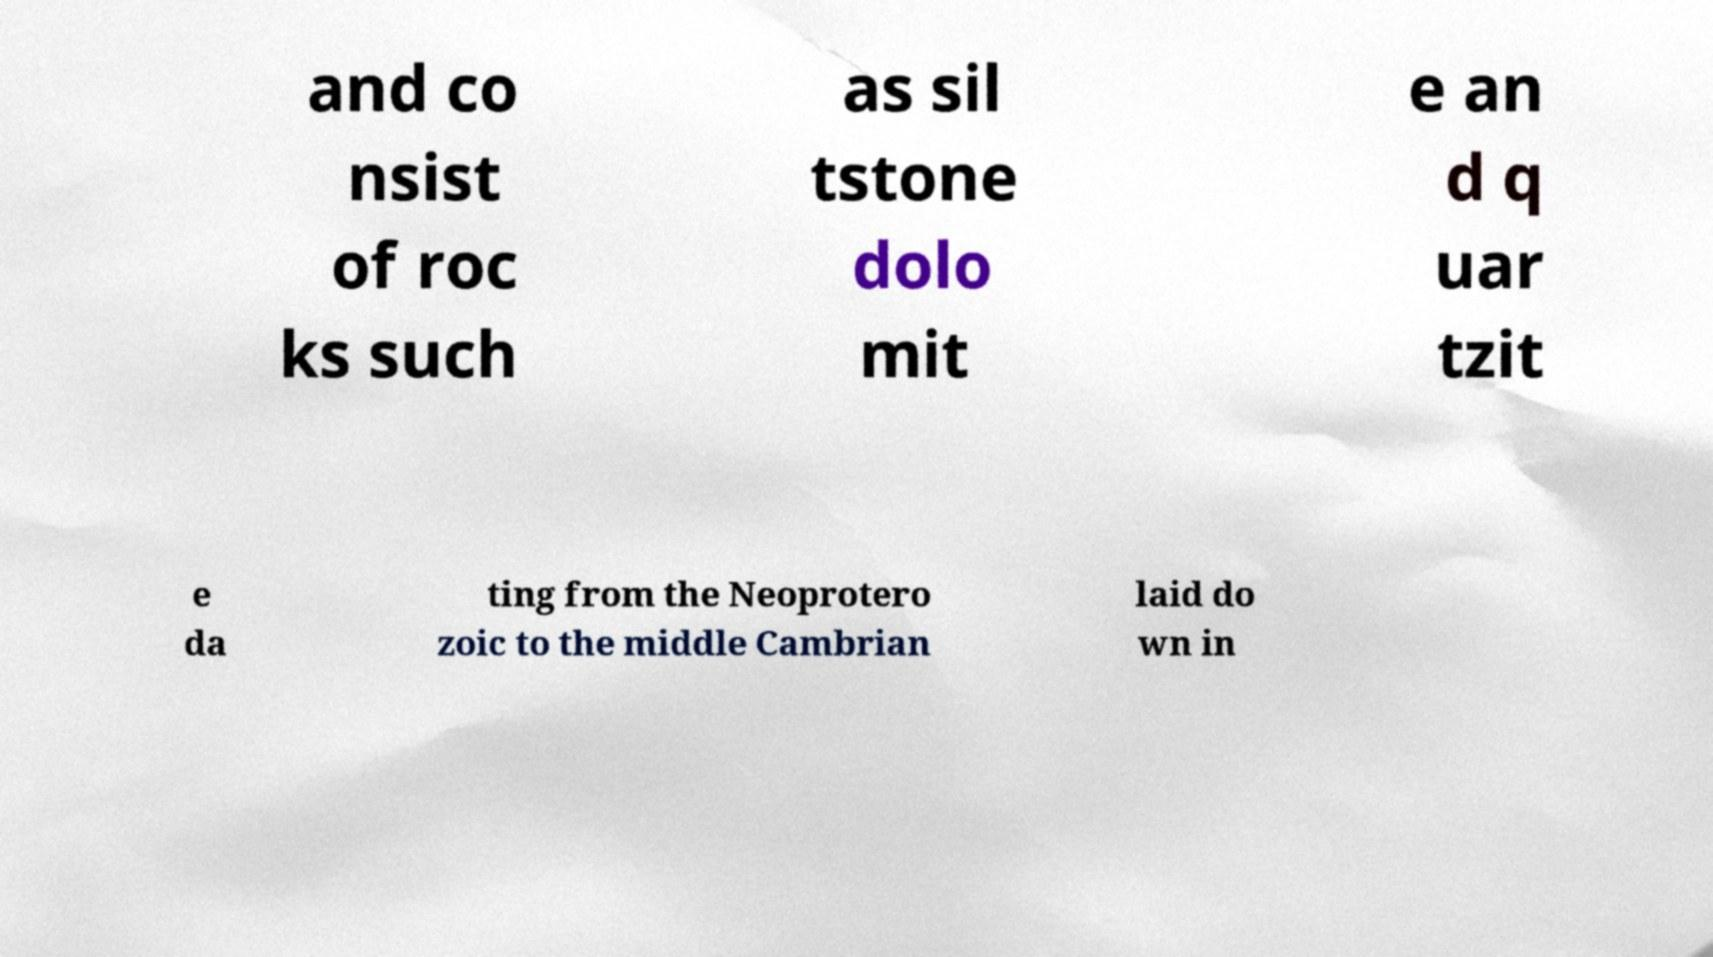Can you read and provide the text displayed in the image?This photo seems to have some interesting text. Can you extract and type it out for me? and co nsist of roc ks such as sil tstone dolo mit e an d q uar tzit e da ting from the Neoprotero zoic to the middle Cambrian laid do wn in 